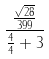Convert formula to latex. <formula><loc_0><loc_0><loc_500><loc_500>\frac { \frac { \sqrt { 2 8 } } { 3 9 9 } } { \frac { 4 } { 4 } + 3 }</formula> 